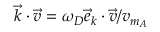Convert formula to latex. <formula><loc_0><loc_0><loc_500><loc_500>\vec { k } \cdot \vec { v } = \omega _ { D } \vec { e } _ { k } \cdot \vec { v } / v _ { m _ { A } }</formula> 